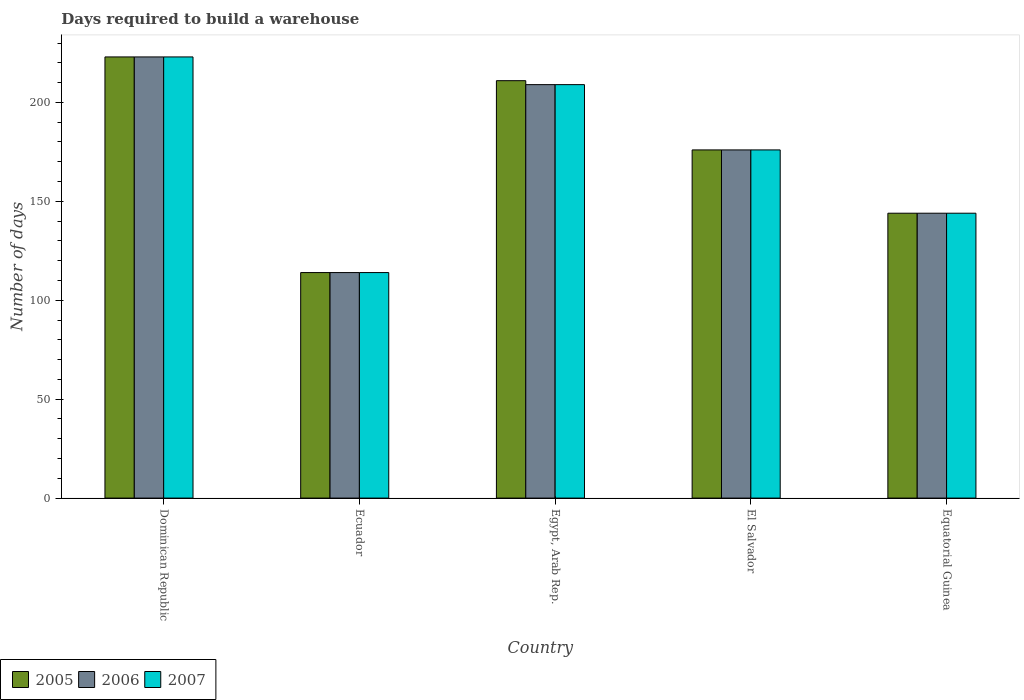How many different coloured bars are there?
Your answer should be compact. 3. Are the number of bars per tick equal to the number of legend labels?
Offer a terse response. Yes. Are the number of bars on each tick of the X-axis equal?
Your answer should be compact. Yes. How many bars are there on the 1st tick from the left?
Your answer should be compact. 3. What is the label of the 5th group of bars from the left?
Give a very brief answer. Equatorial Guinea. In how many cases, is the number of bars for a given country not equal to the number of legend labels?
Your answer should be compact. 0. What is the days required to build a warehouse in in 2007 in Dominican Republic?
Keep it short and to the point. 223. Across all countries, what is the maximum days required to build a warehouse in in 2005?
Provide a short and direct response. 223. Across all countries, what is the minimum days required to build a warehouse in in 2005?
Ensure brevity in your answer.  114. In which country was the days required to build a warehouse in in 2006 maximum?
Keep it short and to the point. Dominican Republic. In which country was the days required to build a warehouse in in 2005 minimum?
Your answer should be very brief. Ecuador. What is the total days required to build a warehouse in in 2007 in the graph?
Your answer should be compact. 866. What is the difference between the days required to build a warehouse in in 2007 in Dominican Republic and that in Equatorial Guinea?
Provide a succinct answer. 79. What is the difference between the days required to build a warehouse in in 2005 in Equatorial Guinea and the days required to build a warehouse in in 2006 in El Salvador?
Make the answer very short. -32. What is the average days required to build a warehouse in in 2006 per country?
Your answer should be compact. 173.2. What is the ratio of the days required to build a warehouse in in 2006 in Ecuador to that in Egypt, Arab Rep.?
Ensure brevity in your answer.  0.55. Is the difference between the days required to build a warehouse in in 2005 in Egypt, Arab Rep. and El Salvador greater than the difference between the days required to build a warehouse in in 2006 in Egypt, Arab Rep. and El Salvador?
Ensure brevity in your answer.  Yes. What is the difference between the highest and the second highest days required to build a warehouse in in 2006?
Your answer should be very brief. -33. What is the difference between the highest and the lowest days required to build a warehouse in in 2005?
Make the answer very short. 109. In how many countries, is the days required to build a warehouse in in 2007 greater than the average days required to build a warehouse in in 2007 taken over all countries?
Ensure brevity in your answer.  3. Is the sum of the days required to build a warehouse in in 2006 in Ecuador and Egypt, Arab Rep. greater than the maximum days required to build a warehouse in in 2005 across all countries?
Ensure brevity in your answer.  Yes. How many bars are there?
Offer a terse response. 15. Are all the bars in the graph horizontal?
Your answer should be very brief. No. Does the graph contain any zero values?
Your answer should be compact. No. How are the legend labels stacked?
Your answer should be compact. Horizontal. What is the title of the graph?
Your answer should be compact. Days required to build a warehouse. Does "2011" appear as one of the legend labels in the graph?
Your answer should be compact. No. What is the label or title of the Y-axis?
Keep it short and to the point. Number of days. What is the Number of days of 2005 in Dominican Republic?
Give a very brief answer. 223. What is the Number of days in 2006 in Dominican Republic?
Make the answer very short. 223. What is the Number of days of 2007 in Dominican Republic?
Make the answer very short. 223. What is the Number of days of 2005 in Ecuador?
Your answer should be compact. 114. What is the Number of days in 2006 in Ecuador?
Your answer should be compact. 114. What is the Number of days in 2007 in Ecuador?
Keep it short and to the point. 114. What is the Number of days of 2005 in Egypt, Arab Rep.?
Keep it short and to the point. 211. What is the Number of days in 2006 in Egypt, Arab Rep.?
Your answer should be very brief. 209. What is the Number of days in 2007 in Egypt, Arab Rep.?
Your answer should be very brief. 209. What is the Number of days in 2005 in El Salvador?
Your answer should be compact. 176. What is the Number of days in 2006 in El Salvador?
Make the answer very short. 176. What is the Number of days in 2007 in El Salvador?
Ensure brevity in your answer.  176. What is the Number of days of 2005 in Equatorial Guinea?
Make the answer very short. 144. What is the Number of days in 2006 in Equatorial Guinea?
Your answer should be very brief. 144. What is the Number of days in 2007 in Equatorial Guinea?
Provide a succinct answer. 144. Across all countries, what is the maximum Number of days of 2005?
Ensure brevity in your answer.  223. Across all countries, what is the maximum Number of days of 2006?
Offer a terse response. 223. Across all countries, what is the maximum Number of days in 2007?
Provide a succinct answer. 223. Across all countries, what is the minimum Number of days of 2005?
Make the answer very short. 114. Across all countries, what is the minimum Number of days of 2006?
Ensure brevity in your answer.  114. Across all countries, what is the minimum Number of days in 2007?
Your answer should be very brief. 114. What is the total Number of days of 2005 in the graph?
Your response must be concise. 868. What is the total Number of days of 2006 in the graph?
Offer a very short reply. 866. What is the total Number of days in 2007 in the graph?
Ensure brevity in your answer.  866. What is the difference between the Number of days of 2005 in Dominican Republic and that in Ecuador?
Your answer should be very brief. 109. What is the difference between the Number of days in 2006 in Dominican Republic and that in Ecuador?
Make the answer very short. 109. What is the difference between the Number of days in 2007 in Dominican Republic and that in Ecuador?
Your answer should be very brief. 109. What is the difference between the Number of days of 2005 in Dominican Republic and that in Egypt, Arab Rep.?
Your response must be concise. 12. What is the difference between the Number of days in 2005 in Dominican Republic and that in El Salvador?
Offer a very short reply. 47. What is the difference between the Number of days in 2006 in Dominican Republic and that in El Salvador?
Give a very brief answer. 47. What is the difference between the Number of days of 2005 in Dominican Republic and that in Equatorial Guinea?
Offer a very short reply. 79. What is the difference between the Number of days of 2006 in Dominican Republic and that in Equatorial Guinea?
Give a very brief answer. 79. What is the difference between the Number of days in 2007 in Dominican Republic and that in Equatorial Guinea?
Give a very brief answer. 79. What is the difference between the Number of days in 2005 in Ecuador and that in Egypt, Arab Rep.?
Your response must be concise. -97. What is the difference between the Number of days of 2006 in Ecuador and that in Egypt, Arab Rep.?
Provide a short and direct response. -95. What is the difference between the Number of days of 2007 in Ecuador and that in Egypt, Arab Rep.?
Offer a very short reply. -95. What is the difference between the Number of days of 2005 in Ecuador and that in El Salvador?
Provide a short and direct response. -62. What is the difference between the Number of days of 2006 in Ecuador and that in El Salvador?
Offer a terse response. -62. What is the difference between the Number of days of 2007 in Ecuador and that in El Salvador?
Give a very brief answer. -62. What is the difference between the Number of days in 2006 in Ecuador and that in Equatorial Guinea?
Offer a terse response. -30. What is the difference between the Number of days in 2005 in Egypt, Arab Rep. and that in El Salvador?
Your answer should be compact. 35. What is the difference between the Number of days of 2005 in Egypt, Arab Rep. and that in Equatorial Guinea?
Offer a terse response. 67. What is the difference between the Number of days of 2005 in El Salvador and that in Equatorial Guinea?
Offer a very short reply. 32. What is the difference between the Number of days of 2006 in El Salvador and that in Equatorial Guinea?
Your answer should be compact. 32. What is the difference between the Number of days of 2007 in El Salvador and that in Equatorial Guinea?
Ensure brevity in your answer.  32. What is the difference between the Number of days of 2005 in Dominican Republic and the Number of days of 2006 in Ecuador?
Give a very brief answer. 109. What is the difference between the Number of days of 2005 in Dominican Republic and the Number of days of 2007 in Ecuador?
Keep it short and to the point. 109. What is the difference between the Number of days of 2006 in Dominican Republic and the Number of days of 2007 in Ecuador?
Provide a short and direct response. 109. What is the difference between the Number of days of 2005 in Dominican Republic and the Number of days of 2007 in Egypt, Arab Rep.?
Make the answer very short. 14. What is the difference between the Number of days of 2006 in Dominican Republic and the Number of days of 2007 in Egypt, Arab Rep.?
Your answer should be compact. 14. What is the difference between the Number of days in 2005 in Dominican Republic and the Number of days in 2006 in El Salvador?
Your answer should be very brief. 47. What is the difference between the Number of days in 2005 in Dominican Republic and the Number of days in 2006 in Equatorial Guinea?
Your response must be concise. 79. What is the difference between the Number of days in 2005 in Dominican Republic and the Number of days in 2007 in Equatorial Guinea?
Your answer should be compact. 79. What is the difference between the Number of days in 2006 in Dominican Republic and the Number of days in 2007 in Equatorial Guinea?
Your response must be concise. 79. What is the difference between the Number of days in 2005 in Ecuador and the Number of days in 2006 in Egypt, Arab Rep.?
Your response must be concise. -95. What is the difference between the Number of days in 2005 in Ecuador and the Number of days in 2007 in Egypt, Arab Rep.?
Keep it short and to the point. -95. What is the difference between the Number of days in 2006 in Ecuador and the Number of days in 2007 in Egypt, Arab Rep.?
Your answer should be compact. -95. What is the difference between the Number of days of 2005 in Ecuador and the Number of days of 2006 in El Salvador?
Offer a very short reply. -62. What is the difference between the Number of days of 2005 in Ecuador and the Number of days of 2007 in El Salvador?
Keep it short and to the point. -62. What is the difference between the Number of days of 2006 in Ecuador and the Number of days of 2007 in El Salvador?
Offer a very short reply. -62. What is the difference between the Number of days of 2005 in Ecuador and the Number of days of 2006 in Equatorial Guinea?
Ensure brevity in your answer.  -30. What is the difference between the Number of days in 2005 in Ecuador and the Number of days in 2007 in Equatorial Guinea?
Give a very brief answer. -30. What is the difference between the Number of days in 2005 in Egypt, Arab Rep. and the Number of days in 2007 in El Salvador?
Offer a very short reply. 35. What is the difference between the Number of days in 2005 in Egypt, Arab Rep. and the Number of days in 2006 in Equatorial Guinea?
Your answer should be very brief. 67. What is the difference between the Number of days in 2006 in Egypt, Arab Rep. and the Number of days in 2007 in Equatorial Guinea?
Your answer should be very brief. 65. What is the difference between the Number of days of 2006 in El Salvador and the Number of days of 2007 in Equatorial Guinea?
Give a very brief answer. 32. What is the average Number of days of 2005 per country?
Provide a short and direct response. 173.6. What is the average Number of days of 2006 per country?
Your response must be concise. 173.2. What is the average Number of days of 2007 per country?
Your answer should be compact. 173.2. What is the difference between the Number of days of 2006 and Number of days of 2007 in Dominican Republic?
Offer a terse response. 0. What is the difference between the Number of days in 2005 and Number of days in 2006 in Ecuador?
Provide a succinct answer. 0. What is the difference between the Number of days of 2005 and Number of days of 2007 in Ecuador?
Offer a very short reply. 0. What is the difference between the Number of days in 2006 and Number of days in 2007 in Ecuador?
Your response must be concise. 0. What is the difference between the Number of days of 2005 and Number of days of 2006 in Egypt, Arab Rep.?
Your answer should be compact. 2. What is the difference between the Number of days in 2005 and Number of days in 2007 in Egypt, Arab Rep.?
Your response must be concise. 2. What is the difference between the Number of days in 2006 and Number of days in 2007 in Egypt, Arab Rep.?
Your answer should be compact. 0. What is the difference between the Number of days of 2005 and Number of days of 2006 in El Salvador?
Your answer should be very brief. 0. What is the difference between the Number of days of 2005 and Number of days of 2006 in Equatorial Guinea?
Your answer should be very brief. 0. What is the difference between the Number of days of 2005 and Number of days of 2007 in Equatorial Guinea?
Offer a terse response. 0. What is the ratio of the Number of days of 2005 in Dominican Republic to that in Ecuador?
Ensure brevity in your answer.  1.96. What is the ratio of the Number of days in 2006 in Dominican Republic to that in Ecuador?
Provide a short and direct response. 1.96. What is the ratio of the Number of days in 2007 in Dominican Republic to that in Ecuador?
Keep it short and to the point. 1.96. What is the ratio of the Number of days of 2005 in Dominican Republic to that in Egypt, Arab Rep.?
Offer a very short reply. 1.06. What is the ratio of the Number of days in 2006 in Dominican Republic to that in Egypt, Arab Rep.?
Offer a very short reply. 1.07. What is the ratio of the Number of days of 2007 in Dominican Republic to that in Egypt, Arab Rep.?
Keep it short and to the point. 1.07. What is the ratio of the Number of days of 2005 in Dominican Republic to that in El Salvador?
Offer a terse response. 1.27. What is the ratio of the Number of days in 2006 in Dominican Republic to that in El Salvador?
Your answer should be compact. 1.27. What is the ratio of the Number of days in 2007 in Dominican Republic to that in El Salvador?
Provide a succinct answer. 1.27. What is the ratio of the Number of days in 2005 in Dominican Republic to that in Equatorial Guinea?
Keep it short and to the point. 1.55. What is the ratio of the Number of days of 2006 in Dominican Republic to that in Equatorial Guinea?
Offer a terse response. 1.55. What is the ratio of the Number of days in 2007 in Dominican Republic to that in Equatorial Guinea?
Your answer should be compact. 1.55. What is the ratio of the Number of days of 2005 in Ecuador to that in Egypt, Arab Rep.?
Your response must be concise. 0.54. What is the ratio of the Number of days in 2006 in Ecuador to that in Egypt, Arab Rep.?
Keep it short and to the point. 0.55. What is the ratio of the Number of days of 2007 in Ecuador to that in Egypt, Arab Rep.?
Provide a short and direct response. 0.55. What is the ratio of the Number of days in 2005 in Ecuador to that in El Salvador?
Keep it short and to the point. 0.65. What is the ratio of the Number of days of 2006 in Ecuador to that in El Salvador?
Ensure brevity in your answer.  0.65. What is the ratio of the Number of days of 2007 in Ecuador to that in El Salvador?
Ensure brevity in your answer.  0.65. What is the ratio of the Number of days of 2005 in Ecuador to that in Equatorial Guinea?
Offer a terse response. 0.79. What is the ratio of the Number of days of 2006 in Ecuador to that in Equatorial Guinea?
Keep it short and to the point. 0.79. What is the ratio of the Number of days in 2007 in Ecuador to that in Equatorial Guinea?
Your answer should be very brief. 0.79. What is the ratio of the Number of days of 2005 in Egypt, Arab Rep. to that in El Salvador?
Offer a very short reply. 1.2. What is the ratio of the Number of days of 2006 in Egypt, Arab Rep. to that in El Salvador?
Provide a succinct answer. 1.19. What is the ratio of the Number of days in 2007 in Egypt, Arab Rep. to that in El Salvador?
Provide a short and direct response. 1.19. What is the ratio of the Number of days in 2005 in Egypt, Arab Rep. to that in Equatorial Guinea?
Ensure brevity in your answer.  1.47. What is the ratio of the Number of days of 2006 in Egypt, Arab Rep. to that in Equatorial Guinea?
Offer a very short reply. 1.45. What is the ratio of the Number of days in 2007 in Egypt, Arab Rep. to that in Equatorial Guinea?
Your response must be concise. 1.45. What is the ratio of the Number of days of 2005 in El Salvador to that in Equatorial Guinea?
Offer a very short reply. 1.22. What is the ratio of the Number of days in 2006 in El Salvador to that in Equatorial Guinea?
Your response must be concise. 1.22. What is the ratio of the Number of days of 2007 in El Salvador to that in Equatorial Guinea?
Keep it short and to the point. 1.22. What is the difference between the highest and the lowest Number of days in 2005?
Provide a succinct answer. 109. What is the difference between the highest and the lowest Number of days of 2006?
Give a very brief answer. 109. What is the difference between the highest and the lowest Number of days in 2007?
Make the answer very short. 109. 